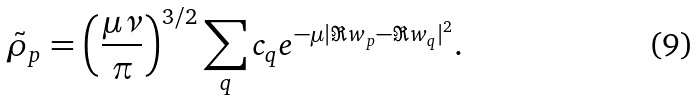Convert formula to latex. <formula><loc_0><loc_0><loc_500><loc_500>\tilde { \rho } _ { p } = \left ( \frac { \mu \nu } { \pi } \right ) ^ { 3 / 2 } \sum _ { q } c _ { q } e ^ { - \mu | \Re { w } _ { p } - \Re { w } _ { q } | ^ { 2 } } .</formula> 